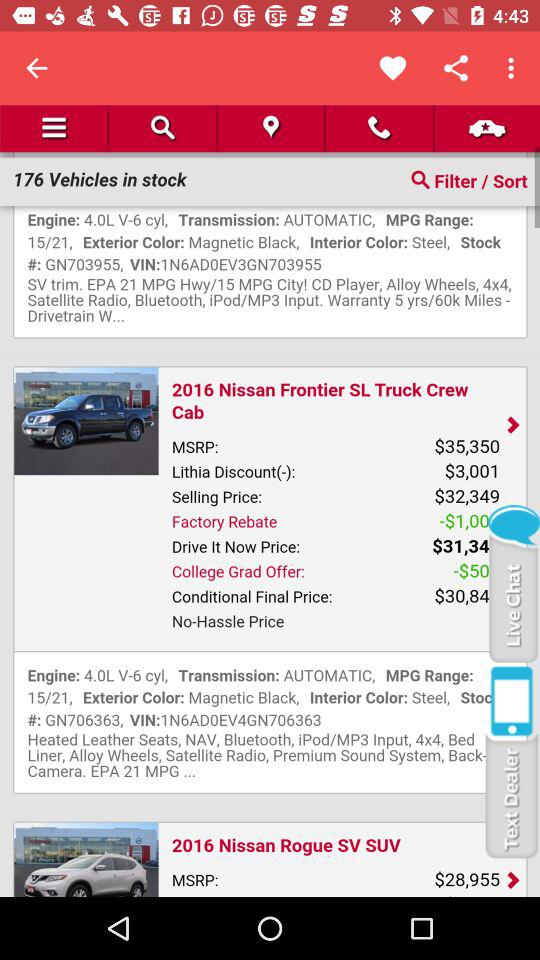What is the exterior color of the "2016 Nissan Frontier SL Truck Crew Cab"? The exterior color is magnetic black. 